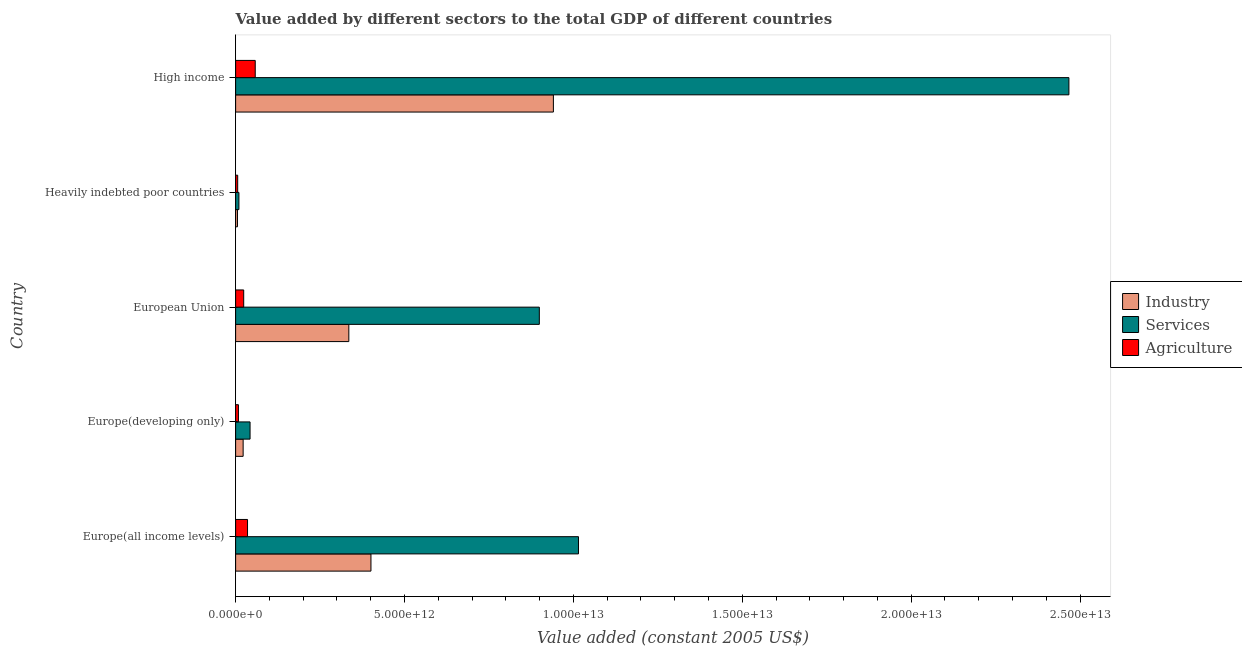How many different coloured bars are there?
Provide a succinct answer. 3. How many groups of bars are there?
Make the answer very short. 5. Are the number of bars on each tick of the Y-axis equal?
Provide a succinct answer. Yes. How many bars are there on the 1st tick from the top?
Provide a short and direct response. 3. How many bars are there on the 1st tick from the bottom?
Offer a terse response. 3. What is the label of the 3rd group of bars from the top?
Offer a very short reply. European Union. In how many cases, is the number of bars for a given country not equal to the number of legend labels?
Make the answer very short. 0. What is the value added by industrial sector in Europe(developing only)?
Your response must be concise. 2.23e+11. Across all countries, what is the maximum value added by industrial sector?
Your answer should be very brief. 9.41e+12. Across all countries, what is the minimum value added by industrial sector?
Offer a terse response. 5.46e+1. In which country was the value added by industrial sector maximum?
Provide a succinct answer. High income. In which country was the value added by services minimum?
Make the answer very short. Heavily indebted poor countries. What is the total value added by agricultural sector in the graph?
Your answer should be compact. 1.32e+12. What is the difference between the value added by agricultural sector in Europe(developing only) and that in High income?
Your answer should be very brief. -4.97e+11. What is the difference between the value added by services in Europe(developing only) and the value added by industrial sector in European Union?
Give a very brief answer. -2.92e+12. What is the average value added by industrial sector per country?
Your answer should be compact. 3.41e+12. What is the difference between the value added by services and value added by agricultural sector in Europe(all income levels)?
Offer a very short reply. 9.80e+12. In how many countries, is the value added by industrial sector greater than 2000000000000 US$?
Provide a short and direct response. 3. What is the ratio of the value added by industrial sector in Europe(all income levels) to that in European Union?
Provide a succinct answer. 1.2. Is the difference between the value added by agricultural sector in Europe(all income levels) and European Union greater than the difference between the value added by services in Europe(all income levels) and European Union?
Provide a succinct answer. No. What is the difference between the highest and the second highest value added by services?
Make the answer very short. 1.45e+13. What is the difference between the highest and the lowest value added by agricultural sector?
Keep it short and to the point. 5.20e+11. What does the 1st bar from the top in Europe(all income levels) represents?
Give a very brief answer. Agriculture. What does the 3rd bar from the bottom in Europe(developing only) represents?
Your answer should be very brief. Agriculture. How many countries are there in the graph?
Provide a short and direct response. 5. What is the difference between two consecutive major ticks on the X-axis?
Offer a very short reply. 5.00e+12. Does the graph contain any zero values?
Offer a very short reply. No. Does the graph contain grids?
Provide a short and direct response. No. What is the title of the graph?
Give a very brief answer. Value added by different sectors to the total GDP of different countries. Does "Methane" appear as one of the legend labels in the graph?
Offer a very short reply. No. What is the label or title of the X-axis?
Your answer should be compact. Value added (constant 2005 US$). What is the Value added (constant 2005 US$) of Industry in Europe(all income levels)?
Offer a very short reply. 4.01e+12. What is the Value added (constant 2005 US$) in Services in Europe(all income levels)?
Your answer should be compact. 1.02e+13. What is the Value added (constant 2005 US$) in Agriculture in Europe(all income levels)?
Make the answer very short. 3.53e+11. What is the Value added (constant 2005 US$) of Industry in Europe(developing only)?
Offer a very short reply. 2.23e+11. What is the Value added (constant 2005 US$) of Services in Europe(developing only)?
Make the answer very short. 4.27e+11. What is the Value added (constant 2005 US$) in Agriculture in Europe(developing only)?
Your response must be concise. 8.37e+1. What is the Value added (constant 2005 US$) in Industry in European Union?
Give a very brief answer. 3.35e+12. What is the Value added (constant 2005 US$) of Services in European Union?
Make the answer very short. 8.99e+12. What is the Value added (constant 2005 US$) in Agriculture in European Union?
Provide a short and direct response. 2.39e+11. What is the Value added (constant 2005 US$) in Industry in Heavily indebted poor countries?
Provide a short and direct response. 5.46e+1. What is the Value added (constant 2005 US$) in Services in Heavily indebted poor countries?
Provide a succinct answer. 9.80e+1. What is the Value added (constant 2005 US$) in Agriculture in Heavily indebted poor countries?
Your answer should be very brief. 6.10e+1. What is the Value added (constant 2005 US$) in Industry in High income?
Offer a terse response. 9.41e+12. What is the Value added (constant 2005 US$) in Services in High income?
Your answer should be compact. 2.47e+13. What is the Value added (constant 2005 US$) of Agriculture in High income?
Make the answer very short. 5.81e+11. Across all countries, what is the maximum Value added (constant 2005 US$) of Industry?
Provide a short and direct response. 9.41e+12. Across all countries, what is the maximum Value added (constant 2005 US$) of Services?
Offer a terse response. 2.47e+13. Across all countries, what is the maximum Value added (constant 2005 US$) in Agriculture?
Provide a short and direct response. 5.81e+11. Across all countries, what is the minimum Value added (constant 2005 US$) of Industry?
Offer a very short reply. 5.46e+1. Across all countries, what is the minimum Value added (constant 2005 US$) of Services?
Ensure brevity in your answer.  9.80e+1. Across all countries, what is the minimum Value added (constant 2005 US$) in Agriculture?
Provide a succinct answer. 6.10e+1. What is the total Value added (constant 2005 US$) in Industry in the graph?
Give a very brief answer. 1.70e+13. What is the total Value added (constant 2005 US$) of Services in the graph?
Keep it short and to the point. 4.43e+13. What is the total Value added (constant 2005 US$) of Agriculture in the graph?
Provide a succinct answer. 1.32e+12. What is the difference between the Value added (constant 2005 US$) in Industry in Europe(all income levels) and that in Europe(developing only)?
Offer a very short reply. 3.78e+12. What is the difference between the Value added (constant 2005 US$) in Services in Europe(all income levels) and that in Europe(developing only)?
Give a very brief answer. 9.72e+12. What is the difference between the Value added (constant 2005 US$) of Agriculture in Europe(all income levels) and that in Europe(developing only)?
Your response must be concise. 2.69e+11. What is the difference between the Value added (constant 2005 US$) of Industry in Europe(all income levels) and that in European Union?
Your answer should be very brief. 6.55e+11. What is the difference between the Value added (constant 2005 US$) of Services in Europe(all income levels) and that in European Union?
Give a very brief answer. 1.16e+12. What is the difference between the Value added (constant 2005 US$) in Agriculture in Europe(all income levels) and that in European Union?
Offer a terse response. 1.13e+11. What is the difference between the Value added (constant 2005 US$) in Industry in Europe(all income levels) and that in Heavily indebted poor countries?
Your answer should be compact. 3.95e+12. What is the difference between the Value added (constant 2005 US$) in Services in Europe(all income levels) and that in Heavily indebted poor countries?
Make the answer very short. 1.01e+13. What is the difference between the Value added (constant 2005 US$) in Agriculture in Europe(all income levels) and that in Heavily indebted poor countries?
Your answer should be compact. 2.92e+11. What is the difference between the Value added (constant 2005 US$) of Industry in Europe(all income levels) and that in High income?
Provide a short and direct response. -5.40e+12. What is the difference between the Value added (constant 2005 US$) of Services in Europe(all income levels) and that in High income?
Make the answer very short. -1.45e+13. What is the difference between the Value added (constant 2005 US$) in Agriculture in Europe(all income levels) and that in High income?
Ensure brevity in your answer.  -2.28e+11. What is the difference between the Value added (constant 2005 US$) in Industry in Europe(developing only) and that in European Union?
Ensure brevity in your answer.  -3.13e+12. What is the difference between the Value added (constant 2005 US$) in Services in Europe(developing only) and that in European Union?
Offer a terse response. -8.56e+12. What is the difference between the Value added (constant 2005 US$) in Agriculture in Europe(developing only) and that in European Union?
Your response must be concise. -1.56e+11. What is the difference between the Value added (constant 2005 US$) of Industry in Europe(developing only) and that in Heavily indebted poor countries?
Provide a short and direct response. 1.68e+11. What is the difference between the Value added (constant 2005 US$) of Services in Europe(developing only) and that in Heavily indebted poor countries?
Give a very brief answer. 3.29e+11. What is the difference between the Value added (constant 2005 US$) in Agriculture in Europe(developing only) and that in Heavily indebted poor countries?
Offer a terse response. 2.27e+1. What is the difference between the Value added (constant 2005 US$) of Industry in Europe(developing only) and that in High income?
Offer a very short reply. -9.19e+12. What is the difference between the Value added (constant 2005 US$) of Services in Europe(developing only) and that in High income?
Give a very brief answer. -2.42e+13. What is the difference between the Value added (constant 2005 US$) of Agriculture in Europe(developing only) and that in High income?
Provide a short and direct response. -4.97e+11. What is the difference between the Value added (constant 2005 US$) in Industry in European Union and that in Heavily indebted poor countries?
Keep it short and to the point. 3.30e+12. What is the difference between the Value added (constant 2005 US$) of Services in European Union and that in Heavily indebted poor countries?
Offer a very short reply. 8.89e+12. What is the difference between the Value added (constant 2005 US$) in Agriculture in European Union and that in Heavily indebted poor countries?
Your answer should be very brief. 1.78e+11. What is the difference between the Value added (constant 2005 US$) in Industry in European Union and that in High income?
Provide a short and direct response. -6.06e+12. What is the difference between the Value added (constant 2005 US$) of Services in European Union and that in High income?
Your answer should be very brief. -1.57e+13. What is the difference between the Value added (constant 2005 US$) in Agriculture in European Union and that in High income?
Keep it short and to the point. -3.41e+11. What is the difference between the Value added (constant 2005 US$) of Industry in Heavily indebted poor countries and that in High income?
Offer a terse response. -9.35e+12. What is the difference between the Value added (constant 2005 US$) of Services in Heavily indebted poor countries and that in High income?
Give a very brief answer. -2.46e+13. What is the difference between the Value added (constant 2005 US$) of Agriculture in Heavily indebted poor countries and that in High income?
Offer a terse response. -5.20e+11. What is the difference between the Value added (constant 2005 US$) of Industry in Europe(all income levels) and the Value added (constant 2005 US$) of Services in Europe(developing only)?
Your response must be concise. 3.58e+12. What is the difference between the Value added (constant 2005 US$) in Industry in Europe(all income levels) and the Value added (constant 2005 US$) in Agriculture in Europe(developing only)?
Provide a succinct answer. 3.92e+12. What is the difference between the Value added (constant 2005 US$) of Services in Europe(all income levels) and the Value added (constant 2005 US$) of Agriculture in Europe(developing only)?
Provide a short and direct response. 1.01e+13. What is the difference between the Value added (constant 2005 US$) in Industry in Europe(all income levels) and the Value added (constant 2005 US$) in Services in European Union?
Offer a terse response. -4.98e+12. What is the difference between the Value added (constant 2005 US$) of Industry in Europe(all income levels) and the Value added (constant 2005 US$) of Agriculture in European Union?
Your answer should be very brief. 3.77e+12. What is the difference between the Value added (constant 2005 US$) in Services in Europe(all income levels) and the Value added (constant 2005 US$) in Agriculture in European Union?
Make the answer very short. 9.91e+12. What is the difference between the Value added (constant 2005 US$) in Industry in Europe(all income levels) and the Value added (constant 2005 US$) in Services in Heavily indebted poor countries?
Give a very brief answer. 3.91e+12. What is the difference between the Value added (constant 2005 US$) of Industry in Europe(all income levels) and the Value added (constant 2005 US$) of Agriculture in Heavily indebted poor countries?
Provide a succinct answer. 3.95e+12. What is the difference between the Value added (constant 2005 US$) of Services in Europe(all income levels) and the Value added (constant 2005 US$) of Agriculture in Heavily indebted poor countries?
Offer a very short reply. 1.01e+13. What is the difference between the Value added (constant 2005 US$) of Industry in Europe(all income levels) and the Value added (constant 2005 US$) of Services in High income?
Your answer should be very brief. -2.07e+13. What is the difference between the Value added (constant 2005 US$) of Industry in Europe(all income levels) and the Value added (constant 2005 US$) of Agriculture in High income?
Provide a short and direct response. 3.43e+12. What is the difference between the Value added (constant 2005 US$) in Services in Europe(all income levels) and the Value added (constant 2005 US$) in Agriculture in High income?
Offer a very short reply. 9.57e+12. What is the difference between the Value added (constant 2005 US$) of Industry in Europe(developing only) and the Value added (constant 2005 US$) of Services in European Union?
Your response must be concise. -8.77e+12. What is the difference between the Value added (constant 2005 US$) of Industry in Europe(developing only) and the Value added (constant 2005 US$) of Agriculture in European Union?
Make the answer very short. -1.67e+1. What is the difference between the Value added (constant 2005 US$) in Services in Europe(developing only) and the Value added (constant 2005 US$) in Agriculture in European Union?
Provide a short and direct response. 1.88e+11. What is the difference between the Value added (constant 2005 US$) of Industry in Europe(developing only) and the Value added (constant 2005 US$) of Services in Heavily indebted poor countries?
Your answer should be compact. 1.25e+11. What is the difference between the Value added (constant 2005 US$) in Industry in Europe(developing only) and the Value added (constant 2005 US$) in Agriculture in Heavily indebted poor countries?
Keep it short and to the point. 1.62e+11. What is the difference between the Value added (constant 2005 US$) of Services in Europe(developing only) and the Value added (constant 2005 US$) of Agriculture in Heavily indebted poor countries?
Your answer should be compact. 3.66e+11. What is the difference between the Value added (constant 2005 US$) of Industry in Europe(developing only) and the Value added (constant 2005 US$) of Services in High income?
Give a very brief answer. -2.44e+13. What is the difference between the Value added (constant 2005 US$) in Industry in Europe(developing only) and the Value added (constant 2005 US$) in Agriculture in High income?
Your answer should be compact. -3.58e+11. What is the difference between the Value added (constant 2005 US$) of Services in Europe(developing only) and the Value added (constant 2005 US$) of Agriculture in High income?
Your answer should be very brief. -1.53e+11. What is the difference between the Value added (constant 2005 US$) in Industry in European Union and the Value added (constant 2005 US$) in Services in Heavily indebted poor countries?
Offer a very short reply. 3.25e+12. What is the difference between the Value added (constant 2005 US$) of Industry in European Union and the Value added (constant 2005 US$) of Agriculture in Heavily indebted poor countries?
Your response must be concise. 3.29e+12. What is the difference between the Value added (constant 2005 US$) of Services in European Union and the Value added (constant 2005 US$) of Agriculture in Heavily indebted poor countries?
Provide a short and direct response. 8.93e+12. What is the difference between the Value added (constant 2005 US$) in Industry in European Union and the Value added (constant 2005 US$) in Services in High income?
Make the answer very short. -2.13e+13. What is the difference between the Value added (constant 2005 US$) in Industry in European Union and the Value added (constant 2005 US$) in Agriculture in High income?
Offer a very short reply. 2.77e+12. What is the difference between the Value added (constant 2005 US$) in Services in European Union and the Value added (constant 2005 US$) in Agriculture in High income?
Provide a succinct answer. 8.41e+12. What is the difference between the Value added (constant 2005 US$) of Industry in Heavily indebted poor countries and the Value added (constant 2005 US$) of Services in High income?
Provide a short and direct response. -2.46e+13. What is the difference between the Value added (constant 2005 US$) of Industry in Heavily indebted poor countries and the Value added (constant 2005 US$) of Agriculture in High income?
Give a very brief answer. -5.26e+11. What is the difference between the Value added (constant 2005 US$) of Services in Heavily indebted poor countries and the Value added (constant 2005 US$) of Agriculture in High income?
Provide a short and direct response. -4.83e+11. What is the average Value added (constant 2005 US$) of Industry per country?
Ensure brevity in your answer.  3.41e+12. What is the average Value added (constant 2005 US$) in Services per country?
Make the answer very short. 8.87e+12. What is the average Value added (constant 2005 US$) in Agriculture per country?
Provide a succinct answer. 2.64e+11. What is the difference between the Value added (constant 2005 US$) of Industry and Value added (constant 2005 US$) of Services in Europe(all income levels)?
Give a very brief answer. -6.14e+12. What is the difference between the Value added (constant 2005 US$) of Industry and Value added (constant 2005 US$) of Agriculture in Europe(all income levels)?
Offer a terse response. 3.65e+12. What is the difference between the Value added (constant 2005 US$) of Services and Value added (constant 2005 US$) of Agriculture in Europe(all income levels)?
Offer a terse response. 9.80e+12. What is the difference between the Value added (constant 2005 US$) in Industry and Value added (constant 2005 US$) in Services in Europe(developing only)?
Give a very brief answer. -2.05e+11. What is the difference between the Value added (constant 2005 US$) in Industry and Value added (constant 2005 US$) in Agriculture in Europe(developing only)?
Ensure brevity in your answer.  1.39e+11. What is the difference between the Value added (constant 2005 US$) of Services and Value added (constant 2005 US$) of Agriculture in Europe(developing only)?
Give a very brief answer. 3.44e+11. What is the difference between the Value added (constant 2005 US$) of Industry and Value added (constant 2005 US$) of Services in European Union?
Give a very brief answer. -5.64e+12. What is the difference between the Value added (constant 2005 US$) of Industry and Value added (constant 2005 US$) of Agriculture in European Union?
Give a very brief answer. 3.11e+12. What is the difference between the Value added (constant 2005 US$) of Services and Value added (constant 2005 US$) of Agriculture in European Union?
Make the answer very short. 8.75e+12. What is the difference between the Value added (constant 2005 US$) of Industry and Value added (constant 2005 US$) of Services in Heavily indebted poor countries?
Offer a very short reply. -4.34e+1. What is the difference between the Value added (constant 2005 US$) of Industry and Value added (constant 2005 US$) of Agriculture in Heavily indebted poor countries?
Give a very brief answer. -6.43e+09. What is the difference between the Value added (constant 2005 US$) of Services and Value added (constant 2005 US$) of Agriculture in Heavily indebted poor countries?
Keep it short and to the point. 3.70e+1. What is the difference between the Value added (constant 2005 US$) in Industry and Value added (constant 2005 US$) in Services in High income?
Offer a very short reply. -1.53e+13. What is the difference between the Value added (constant 2005 US$) in Industry and Value added (constant 2005 US$) in Agriculture in High income?
Provide a short and direct response. 8.83e+12. What is the difference between the Value added (constant 2005 US$) in Services and Value added (constant 2005 US$) in Agriculture in High income?
Offer a very short reply. 2.41e+13. What is the ratio of the Value added (constant 2005 US$) in Industry in Europe(all income levels) to that in Europe(developing only)?
Offer a very short reply. 17.99. What is the ratio of the Value added (constant 2005 US$) in Services in Europe(all income levels) to that in Europe(developing only)?
Your response must be concise. 23.75. What is the ratio of the Value added (constant 2005 US$) of Agriculture in Europe(all income levels) to that in Europe(developing only)?
Your response must be concise. 4.21. What is the ratio of the Value added (constant 2005 US$) of Industry in Europe(all income levels) to that in European Union?
Your response must be concise. 1.2. What is the ratio of the Value added (constant 2005 US$) of Services in Europe(all income levels) to that in European Union?
Give a very brief answer. 1.13. What is the ratio of the Value added (constant 2005 US$) of Agriculture in Europe(all income levels) to that in European Union?
Offer a very short reply. 1.47. What is the ratio of the Value added (constant 2005 US$) in Industry in Europe(all income levels) to that in Heavily indebted poor countries?
Your answer should be compact. 73.37. What is the ratio of the Value added (constant 2005 US$) of Services in Europe(all income levels) to that in Heavily indebted poor countries?
Provide a short and direct response. 103.54. What is the ratio of the Value added (constant 2005 US$) of Agriculture in Europe(all income levels) to that in Heavily indebted poor countries?
Make the answer very short. 5.78. What is the ratio of the Value added (constant 2005 US$) in Industry in Europe(all income levels) to that in High income?
Provide a short and direct response. 0.43. What is the ratio of the Value added (constant 2005 US$) in Services in Europe(all income levels) to that in High income?
Your response must be concise. 0.41. What is the ratio of the Value added (constant 2005 US$) in Agriculture in Europe(all income levels) to that in High income?
Your answer should be very brief. 0.61. What is the ratio of the Value added (constant 2005 US$) in Industry in Europe(developing only) to that in European Union?
Offer a very short reply. 0.07. What is the ratio of the Value added (constant 2005 US$) in Services in Europe(developing only) to that in European Union?
Keep it short and to the point. 0.05. What is the ratio of the Value added (constant 2005 US$) in Agriculture in Europe(developing only) to that in European Union?
Provide a succinct answer. 0.35. What is the ratio of the Value added (constant 2005 US$) in Industry in Europe(developing only) to that in Heavily indebted poor countries?
Offer a very short reply. 4.08. What is the ratio of the Value added (constant 2005 US$) of Services in Europe(developing only) to that in Heavily indebted poor countries?
Provide a short and direct response. 4.36. What is the ratio of the Value added (constant 2005 US$) of Agriculture in Europe(developing only) to that in Heavily indebted poor countries?
Give a very brief answer. 1.37. What is the ratio of the Value added (constant 2005 US$) in Industry in Europe(developing only) to that in High income?
Your answer should be compact. 0.02. What is the ratio of the Value added (constant 2005 US$) of Services in Europe(developing only) to that in High income?
Provide a succinct answer. 0.02. What is the ratio of the Value added (constant 2005 US$) in Agriculture in Europe(developing only) to that in High income?
Provide a short and direct response. 0.14. What is the ratio of the Value added (constant 2005 US$) of Industry in European Union to that in Heavily indebted poor countries?
Give a very brief answer. 61.37. What is the ratio of the Value added (constant 2005 US$) in Services in European Union to that in Heavily indebted poor countries?
Offer a very short reply. 91.71. What is the ratio of the Value added (constant 2005 US$) in Agriculture in European Union to that in Heavily indebted poor countries?
Your response must be concise. 3.92. What is the ratio of the Value added (constant 2005 US$) in Industry in European Union to that in High income?
Offer a very short reply. 0.36. What is the ratio of the Value added (constant 2005 US$) in Services in European Union to that in High income?
Your answer should be very brief. 0.36. What is the ratio of the Value added (constant 2005 US$) of Agriculture in European Union to that in High income?
Keep it short and to the point. 0.41. What is the ratio of the Value added (constant 2005 US$) of Industry in Heavily indebted poor countries to that in High income?
Your answer should be very brief. 0.01. What is the ratio of the Value added (constant 2005 US$) in Services in Heavily indebted poor countries to that in High income?
Your response must be concise. 0. What is the ratio of the Value added (constant 2005 US$) in Agriculture in Heavily indebted poor countries to that in High income?
Your answer should be compact. 0.11. What is the difference between the highest and the second highest Value added (constant 2005 US$) of Industry?
Your answer should be very brief. 5.40e+12. What is the difference between the highest and the second highest Value added (constant 2005 US$) of Services?
Ensure brevity in your answer.  1.45e+13. What is the difference between the highest and the second highest Value added (constant 2005 US$) in Agriculture?
Your answer should be compact. 2.28e+11. What is the difference between the highest and the lowest Value added (constant 2005 US$) in Industry?
Make the answer very short. 9.35e+12. What is the difference between the highest and the lowest Value added (constant 2005 US$) of Services?
Ensure brevity in your answer.  2.46e+13. What is the difference between the highest and the lowest Value added (constant 2005 US$) of Agriculture?
Ensure brevity in your answer.  5.20e+11. 